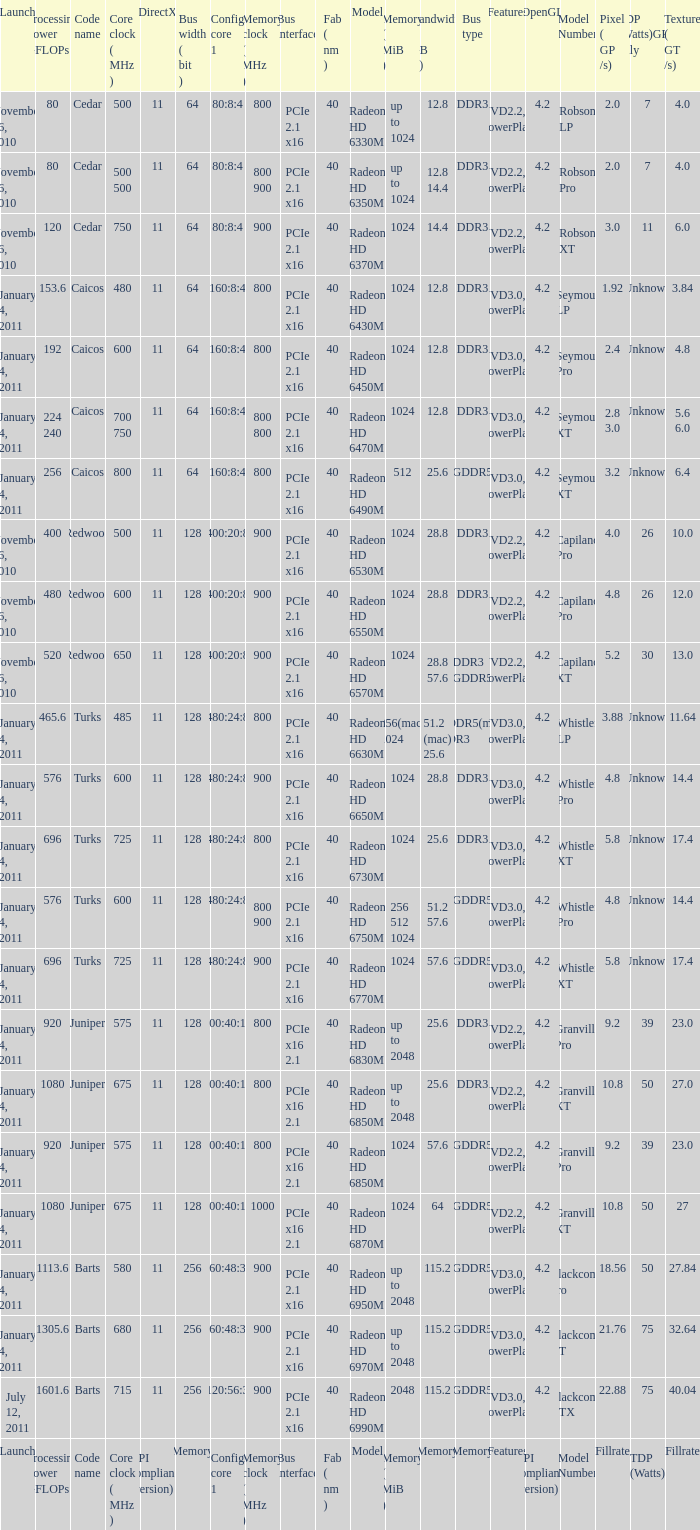What is every code name for the model Radeon HD 6650m? Turks. 